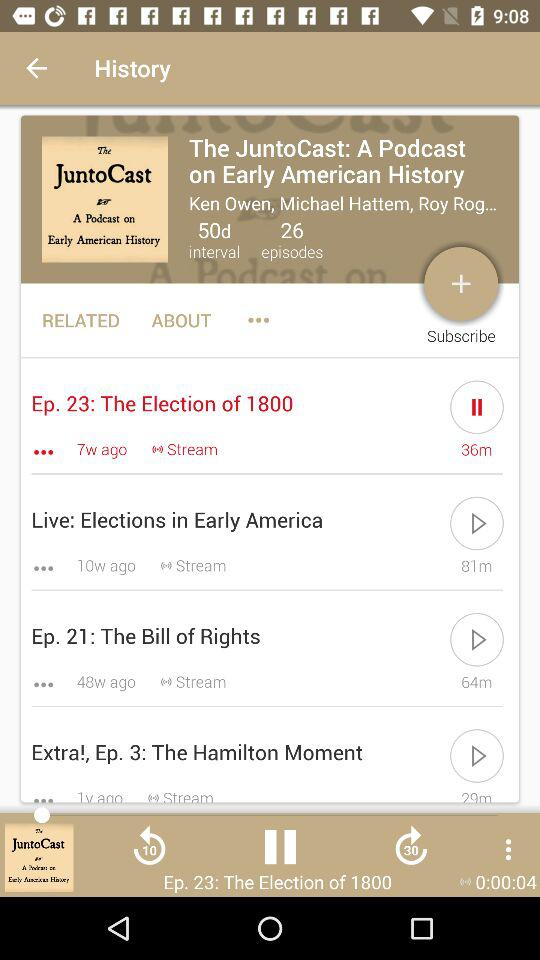How many episodes are there in total? There are 26 episodes. 